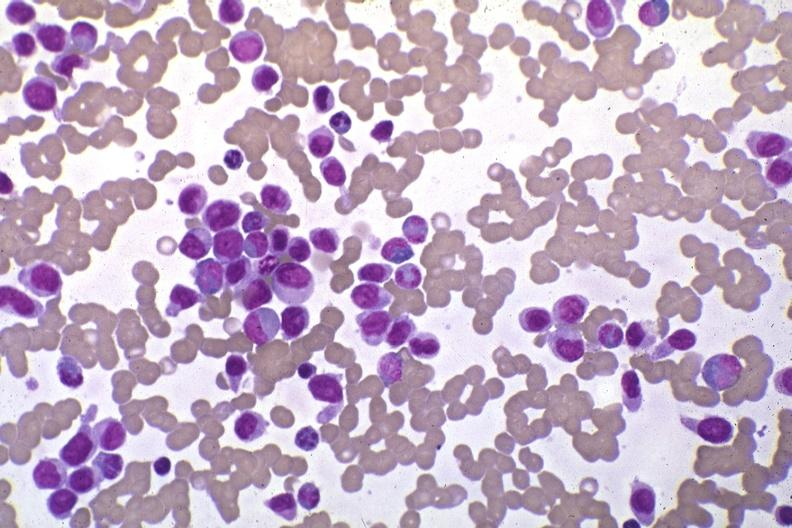what is present?
Answer the question using a single word or phrase. Hematologic 